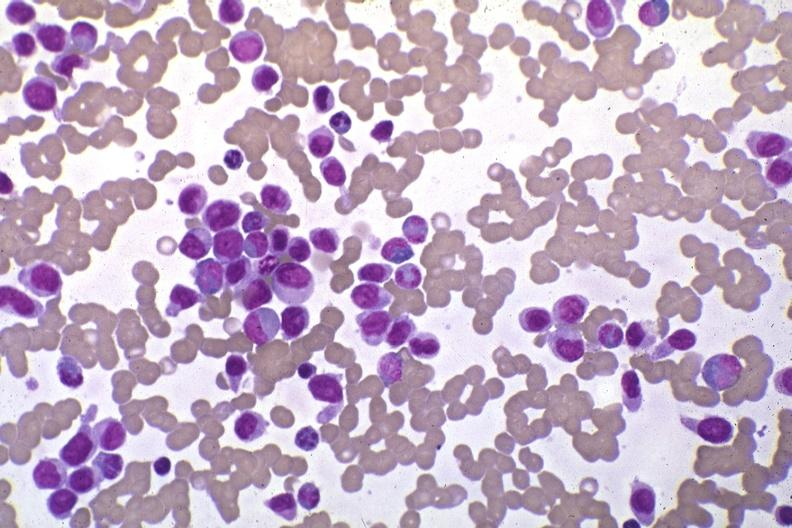what is present?
Answer the question using a single word or phrase. Hematologic 